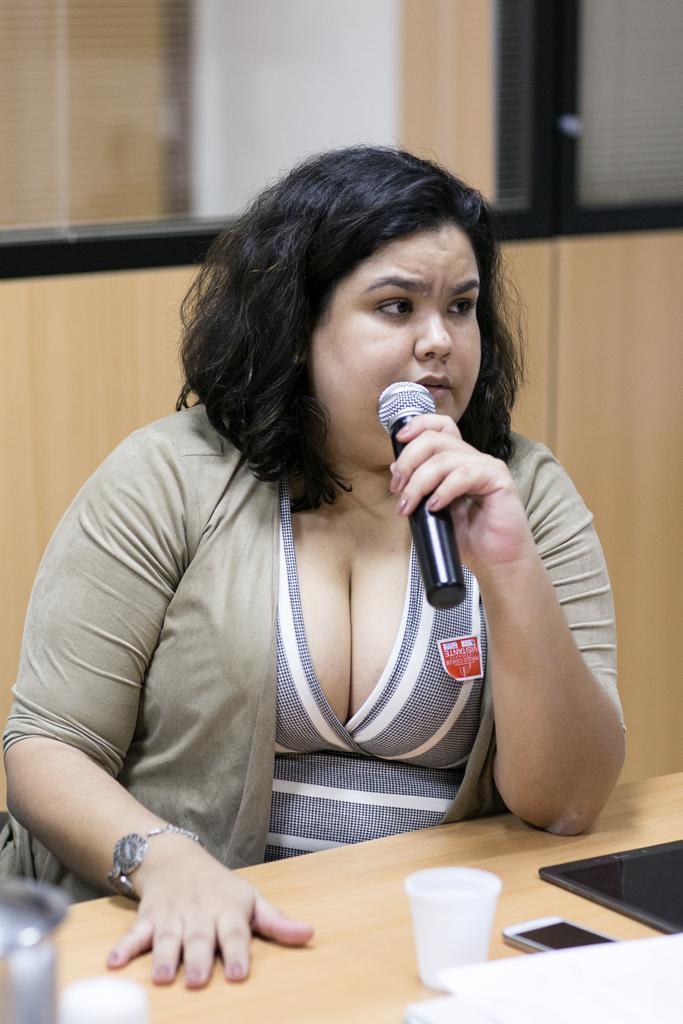Could you give a brief overview of what you see in this image? A woman wearing a watch is sitting and holding a mic. On front of her there is a table. On the table there is a cup, mobile and some other item. In the background there is a wooden wall and a glass. 